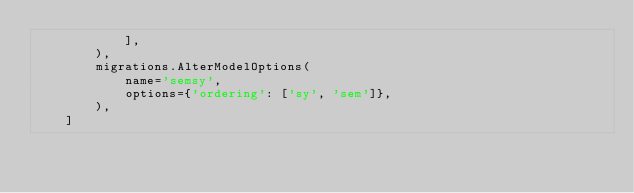Convert code to text. <code><loc_0><loc_0><loc_500><loc_500><_Python_>            ],
        ),
        migrations.AlterModelOptions(
            name='semsy',
            options={'ordering': ['sy', 'sem']},
        ),
    ]
</code> 